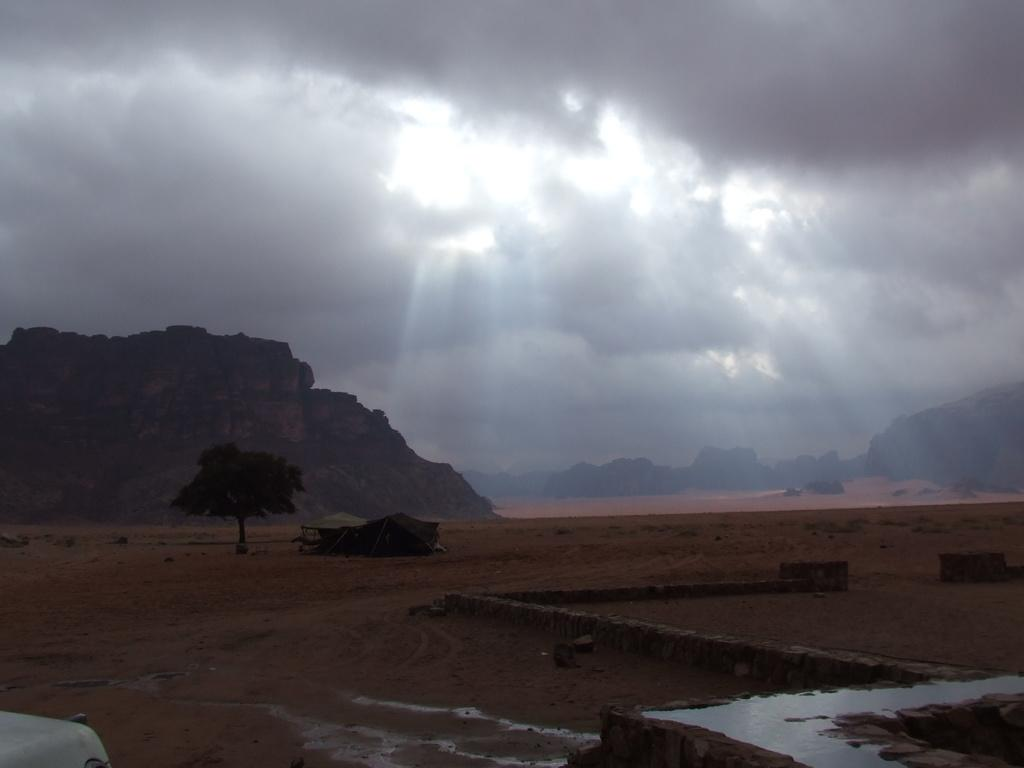What type of water is present in the image? There is groundwater in the image. What type of structure can be seen in the image? There is a shed in the image. What type of plant is present in the image? There is a tree in the image. What type of geological feature is visible in the background of the image? There are cliffs visible in the background of the image. What is visible in the sky in the image? The sky is visible in the background of the image, and clouds are present. Can you tell me how many ducks are swimming in the groundwater in the image? There are no ducks present in the image; it features groundwater, a shed, a tree, cliffs, and clouds in the sky. 